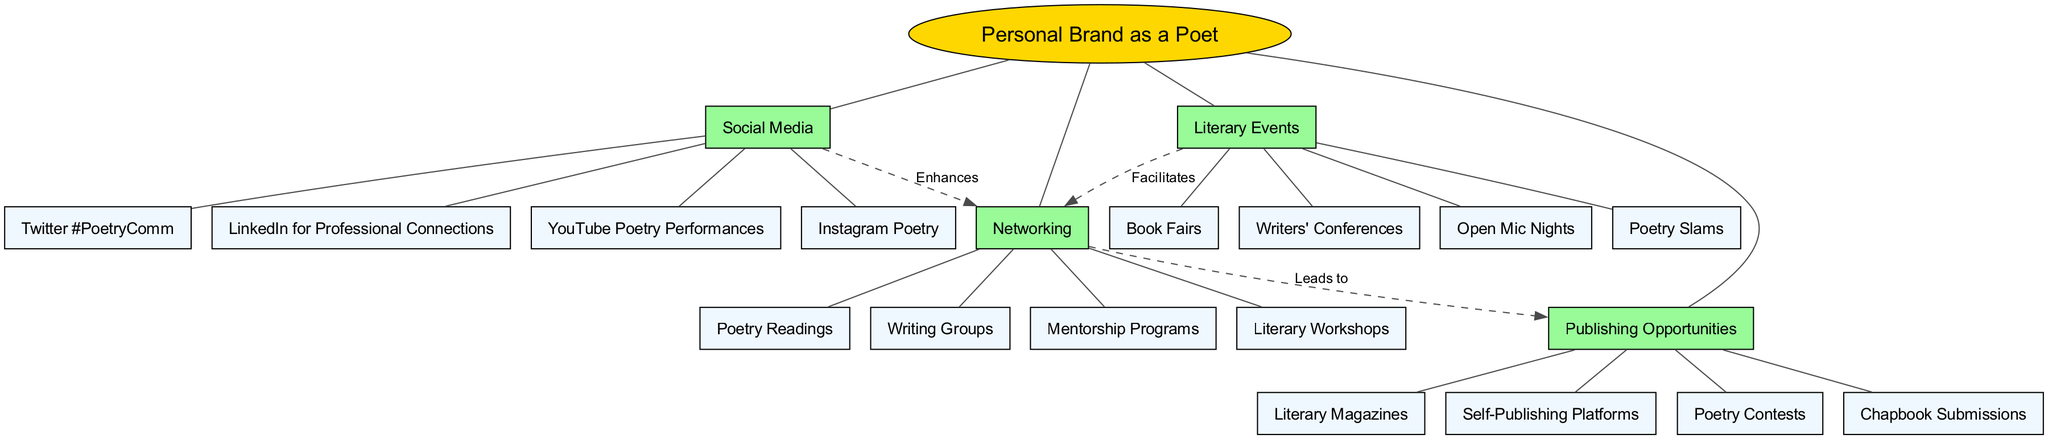What's the central concept of the diagram? The diagram clearly labels the central concept at its center, which is "Personal Brand as a Poet". Therefore, this gives a direct identification of the main focus of the concept map.
Answer: Personal Brand as a Poet How many main branches are there in the diagram? The diagram depicts four main branches emanating from the central concept. By counting each of the branches listed, we confirm the total number.
Answer: Four What label connects "Networking" and "Publishing Opportunities"? The diagram includes a dashed edge connecting these two nodes with the label "Leads to", directly referencing how networking can help in finding publishing opportunities.
Answer: Leads to What are two sub-branches under "Social Media"? The diagram lists several sub-branches connected to "Social Media." Two of these can be directly selected based on their clear representation in the diagram.
Answer: Instagram Poetry, Twitter #PoetryComm Which branch facilitates connections to "Networking"? In the diagram, "Literary Events" is indicated with a dashed edge leading to "Networking". This specifies that literary events are a way to build connections with others in the writing community.
Answer: Literary Events What relationship exists between "Social Media" and "Networking"? The diagram delineates that "Social Media" enhances "Networking." This means that engaging on social media platforms can improve opportunities for networking.
Answer: Enhances How many sub-branches are there under "Literary Events"? When examining the "Literary Events" branch in the diagram, we can see that it has four distinct sub-branches listed below it. Therefore, the total can be counted directly from their representation.
Answer: Four What is one publishing opportunity listed under the "Publishing Opportunities" branch? The diagram features multiple sub-branches under "Publishing Opportunities," one of which can be easily identified as a form of publishing where poets can submit their work.
Answer: Poetry Contests Which main branch includes "Mentorship Programs"? The central branch from which "Mentorship Programs" is delineated is "Networking," as it is explicitly shown as a sub-branch beneath that main branch in the diagram.
Answer: Networking 